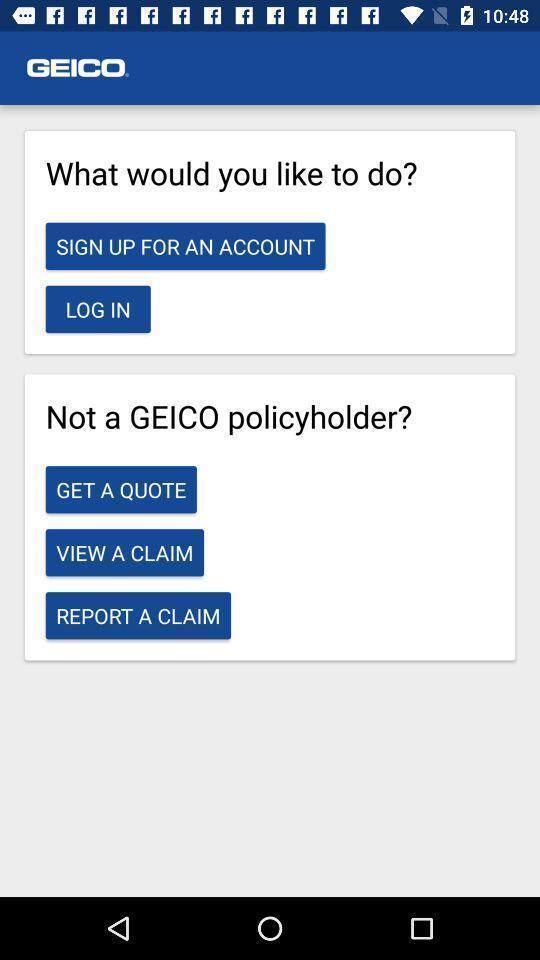Provide a description of this screenshot. Various questions displayed. 